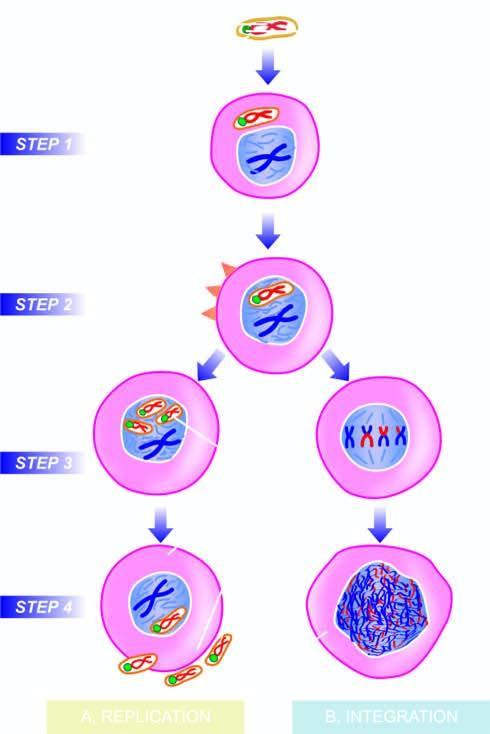s the sinuses expressed immediately after infection?
Answer the question using a single word or phrase. No 